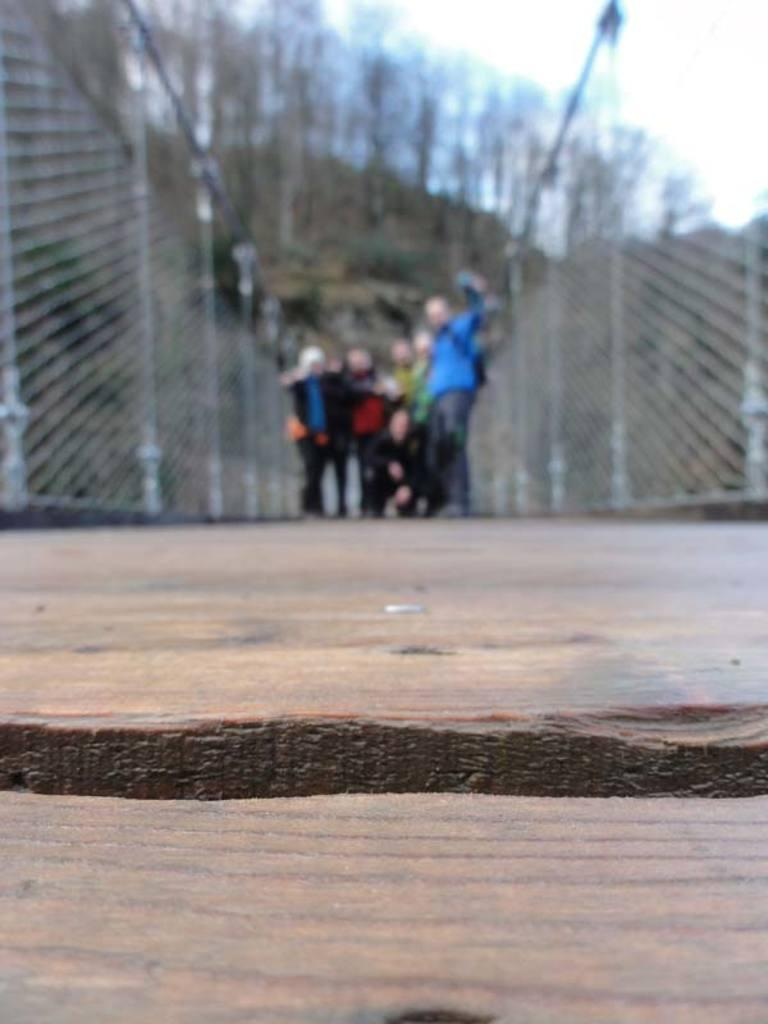What type of structure is present in the image? There is a wooden platform in the image. What surrounds the wooden platform? There are fences in the image. Are there any people in the image? Yes, there are people standing in the image. What type of natural elements can be seen in the image? There are trees in the image. What can be seen in the background of the image? The sky is visible in the background of the image. What type of rock is being used for pleasure in the image? There is no rock or activity related to pleasure present in the image. 